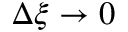Convert formula to latex. <formula><loc_0><loc_0><loc_500><loc_500>\Delta \xi \to 0</formula> 